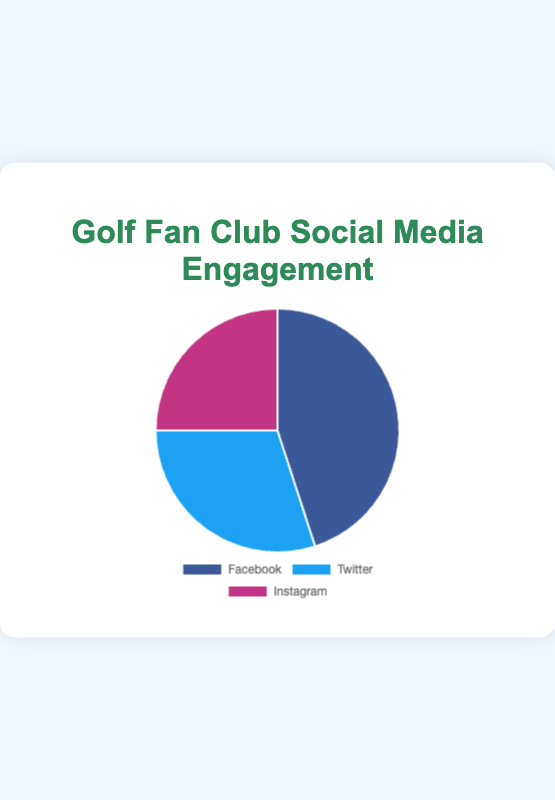Which social media platform has the highest engagement percentage? By looking at the pie chart, the segment representing Facebook is the largest with 45%, indicating that it has the highest engagement percentage compared to Twitter and Instagram.
Answer: Facebook Which social media platform has the lowest engagement percentage? The smallest segment in the pie chart represents Instagram, with an engagement percentage of 25%.
Answer: Instagram How does the engagement percentage of Twitter compare to Facebook? Twitter has an engagement percentage of 30%, while Facebook has 45%. Therefore, Twitter has a lower engagement percentage compared to Facebook.
Answer: Facebook > Twitter What is the combined engagement percentage of Twitter and Instagram? The engagement percentage for Twitter is 30% and for Instagram is 25%. Adding these together gives 30% + 25% = 55%.
Answer: 55% If you combine the engagement percentages of Facebook and Instagram, how does it compare to Twitter's engagement percentage? The engagement percentage of Facebook is 45% and Instagram is 25%. Combined, they are 45% + 25% = 70%. Twitter has an engagement percentage of 30%, which means the combined engagement of Facebook and Instagram (70%) is much higher than Twitter's (30%).
Answer: Facebook + Instagram > Twitter What sources contribute to Facebook engagement as seen in the chart? The engagement sources for Facebook are listed as Event Promotions, Member Interactions, and Fundraising Campaigns.
Answer: Event Promotions, Member Interactions, Fundraising Campaigns Which social media platform’s engagement sources include Live Event Updates? According to the pie chart, Live Event Updates is listed as an engagement source for Twitter.
Answer: Twitter What is the percentage difference between the engagement of Facebook and Instagram? Facebook has an engagement percentage of 45% and Instagram has 25%. The difference is 45% - 25% = 20%.
Answer: 20% What proportion of the total engagement percentage comes from Instagram activities like Photo/Videos Shares, Stories, and Reels? Instagram's activities contribute 25% to the total engagement as shown in the pie chart.
Answer: 25% Which social media platform is represented by the pink section in the pie chart? The pink (or magenta) section of the pie chart represents Instagram.
Answer: Instagram 